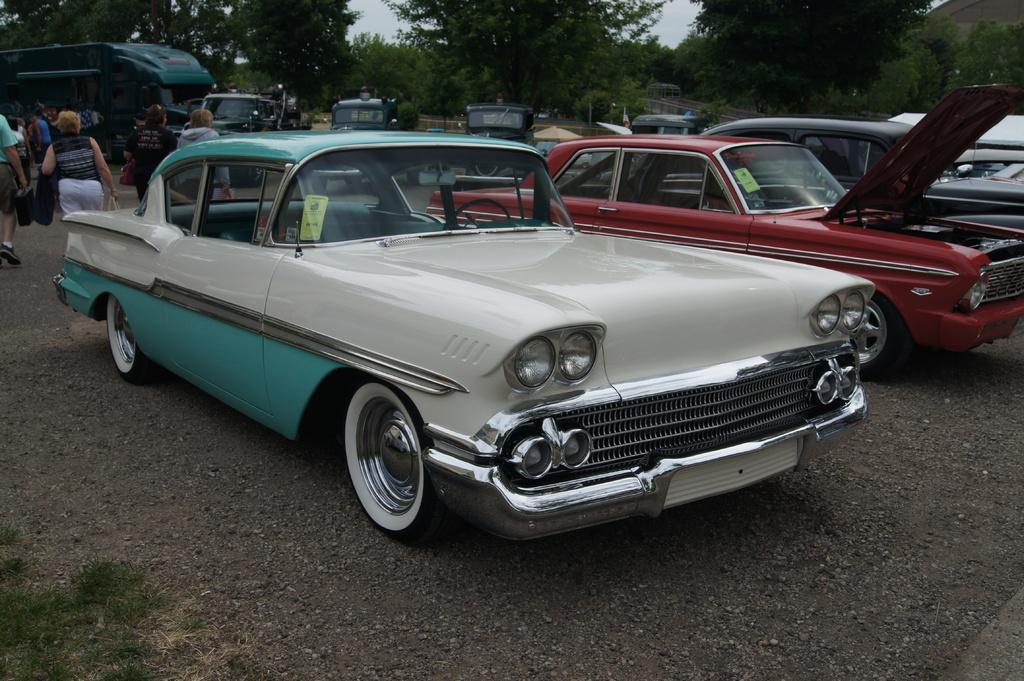Could you give a brief overview of what you see in this image? In the image in the center we can see few different color vehicles. And we can see few people were walking and they were holding some objects. In the background we can see sky,clouds and trees. 